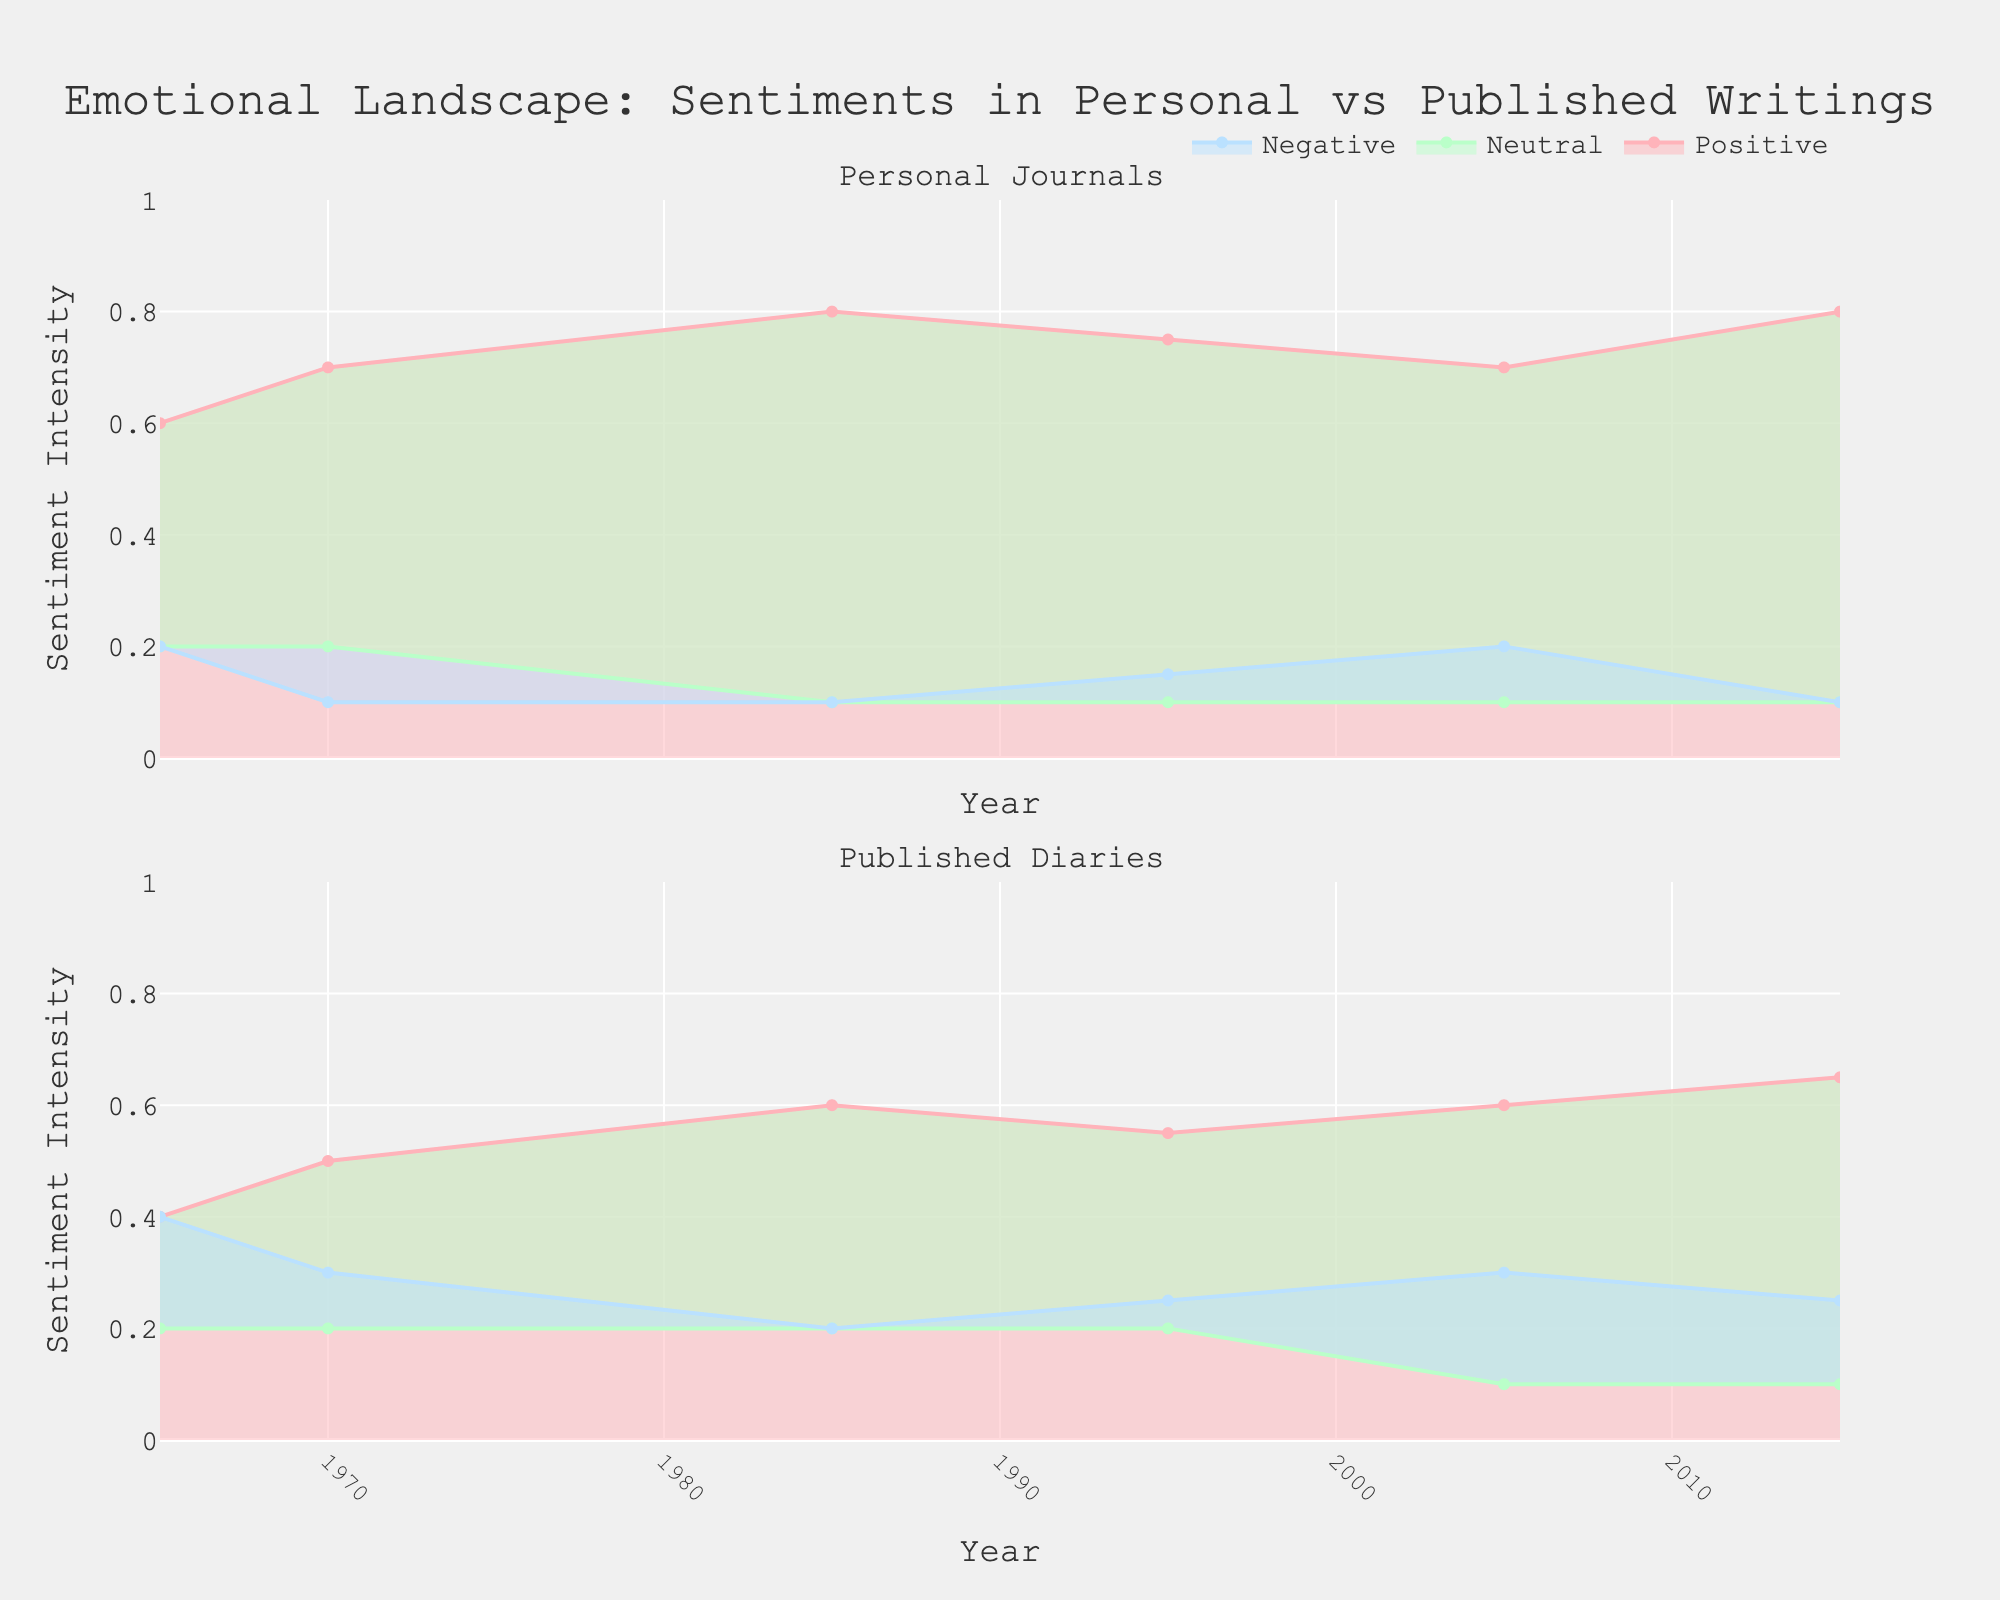Which subplot shows higher positive sentiment for the year 1985? In the 1985 data, the positive sentiment for personal journals is higher, with a level of 0.8 compared to 0.6 in published diaries. This can be seen by observing the first subplot (Personal Journals) and comparing it with the second subplot (Published Diaries).
Answer: Personal Journals What title is given to the overall figure? The figure is titled "Emotional Landscape: Sentiments in Personal vs Published Writings." This information is prominently displayed at the top of the figure.
Answer: Emotional Landscape: Sentiments in Personal vs Published Writings Which author type shows a consistent increase in positive sentiment over the years? By observing the trends in both subplots, the positive sentiment in personal journals consistently increases over time from 0.6 in 1965 to 0.8 in 2015. The lines filled with pink color in the first subplot confirm this.
Answer: Personal Journals Compare the negative sentiments between personal journals and published diaries in 2005. The negative sentiment in personal journals for 2005 is 0.2, while in published diaries, it is 0.3. This can be seen by observing the blue shaded area in both subplots for the year 2005.
Answer: Personal Journals: 0.2, Published Diaries: 0.3 What is the observation regarding the trend of neutral sentiment in published diaries? Observing the second subplot, the neutral sentiment in published diaries remains constant at 0.2 from 1965 to 1995 and slightly decreases to 0.1 in 2005 and 2015. This can be identified by looking at the green shaded areas in the second subplot.
Answer: Decreased slightly What is the difference in positive sentiment between personal journals and published diaries in the year 1995? In 1995, the positive sentiment for personal journals is 0.75, while for published diaries, it is 0.55. The difference can be calculated as 0.75 - 0.55 = 0.2. This can be confirmed by the pink shaded lines in both subplots for the year 1995.
Answer: 0.2 How does the neutral sentiment vary between personal journals from 1985 to 2015? For personal journals, the neutral sentiment starts at 0.1 in 1985 and remains constant at 0.1 through 2015. This can be ascertained by examining the green shaded areas in the first subplot.
Answer: Stays constant at 0.1 What is the range of years displayed on the x-axis? The x-axis displays the range of years from 1965 to 2015, as observed from the x-axis labels in both subplots.
Answer: 1965 to 2015 Identify the author type and sentiment type that shows the highest recorded sentiment in any given year. The highest recorded sentiment is for positive sentiment in personal journals in 2015, reaching up to 0.8. This is observed in the pink area of the first subplot for the year 2015.
Answer: Personal journals, positive sentiment Which sentiment type for published diaries shows the slowest change over time? Neutral sentiment in published diaries shows the slowest change over time, remaining constant at 0.2 until 1995 and then slightly decreasing to 0.1. This can be observed in the green areas of the second subplot.
Answer: Neutral sentiment 